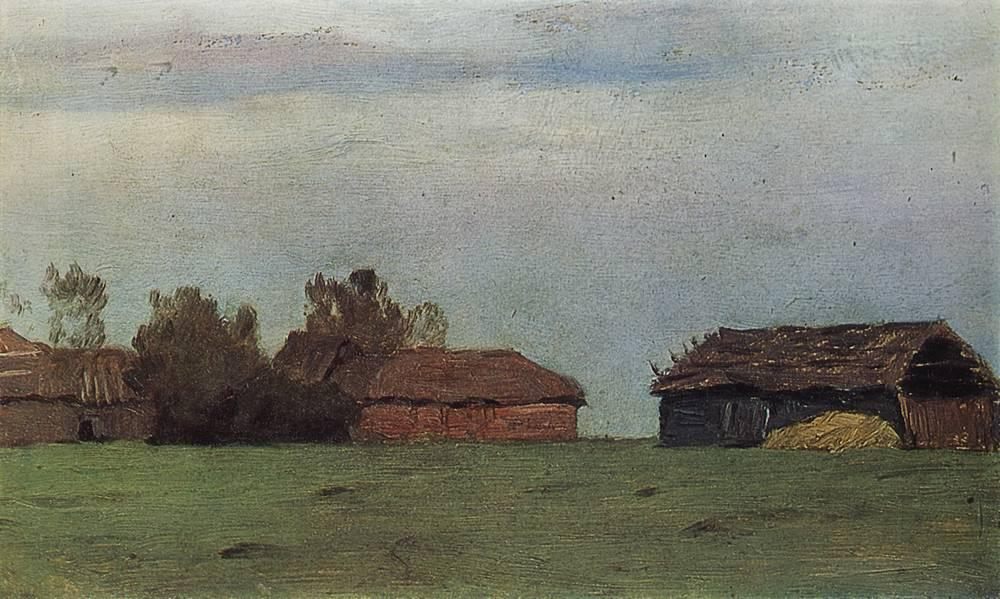What might the condition of these buildings tell us about the location? The dilapidated state of the buildings, combined with their rustic wooden construction, indicates a rural setting possibly prone to economic hardships or a location that has seen a decline in agricultural activity over time. And do you think these buildings are still in use? Given their considerable disrepair, it is unlikely that these buildings are still actively used for any substantial agricultural purpose. They might be used for storage or have been abandoned. 